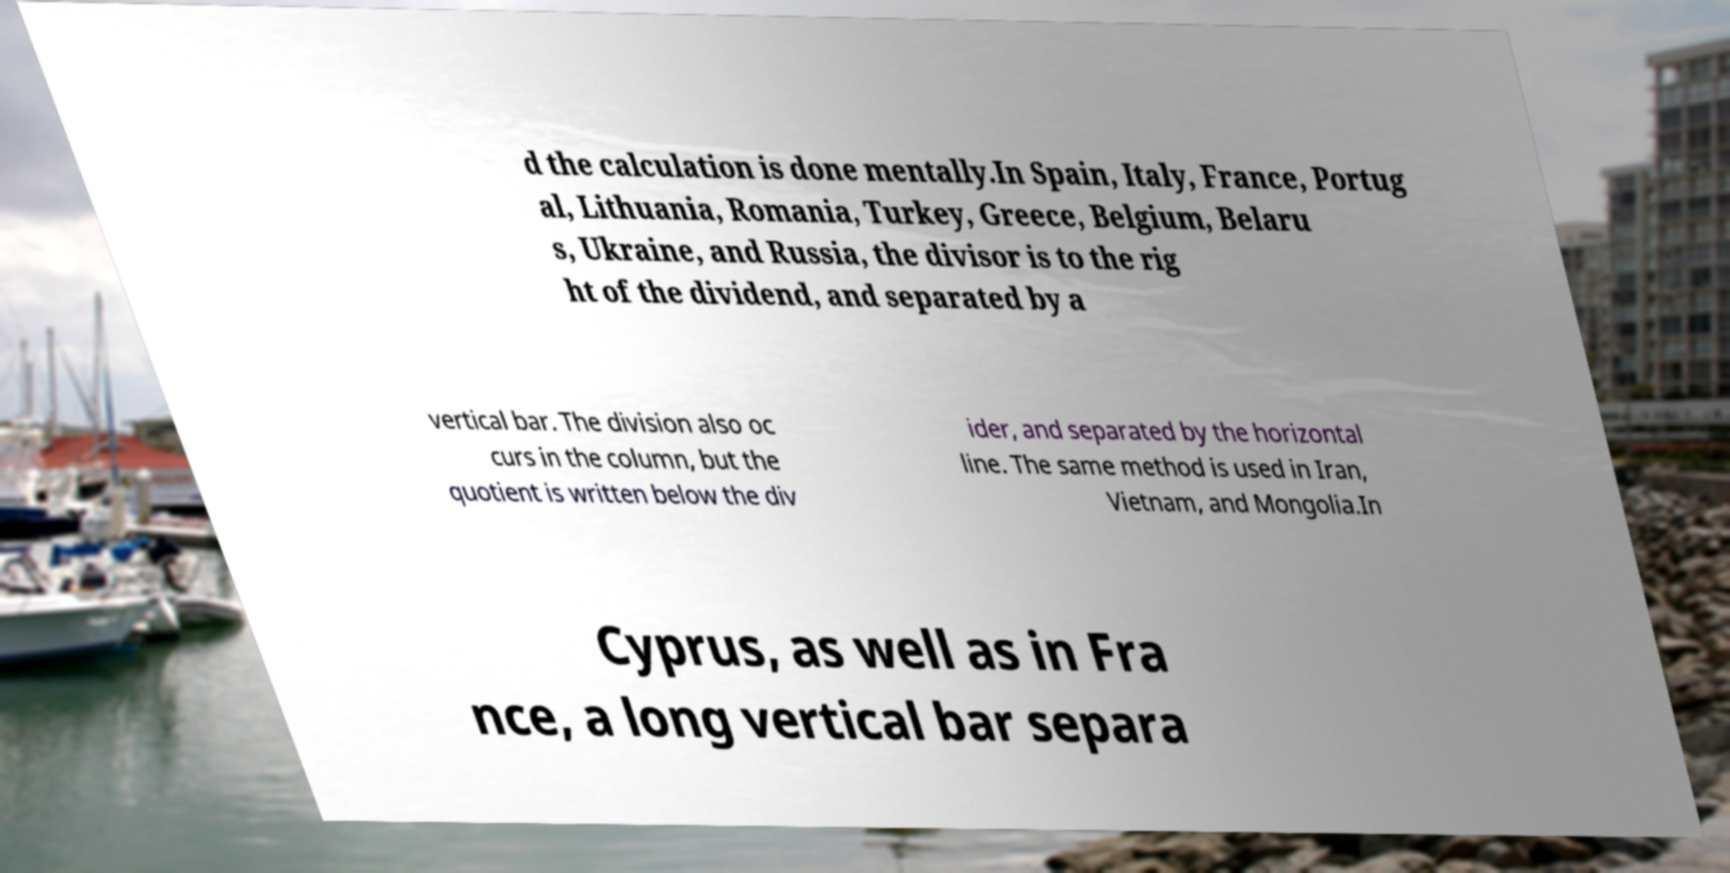I need the written content from this picture converted into text. Can you do that? d the calculation is done mentally.In Spain, Italy, France, Portug al, Lithuania, Romania, Turkey, Greece, Belgium, Belaru s, Ukraine, and Russia, the divisor is to the rig ht of the dividend, and separated by a vertical bar. The division also oc curs in the column, but the quotient is written below the div ider, and separated by the horizontal line. The same method is used in Iran, Vietnam, and Mongolia.In Cyprus, as well as in Fra nce, a long vertical bar separa 